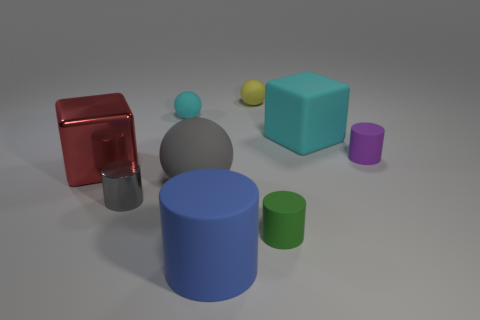Subtract 2 blocks. How many blocks are left? 0 Subtract all cyan spheres. How many spheres are left? 2 Subtract all small balls. How many balls are left? 1 Add 5 small purple rubber cylinders. How many small purple rubber cylinders exist? 6 Subtract 0 blue balls. How many objects are left? 9 Subtract all cylinders. How many objects are left? 5 Subtract all green cylinders. Subtract all yellow spheres. How many cylinders are left? 3 Subtract all red blocks. How many blue cylinders are left? 1 Subtract all small purple rubber cylinders. Subtract all tiny spheres. How many objects are left? 6 Add 3 large blue matte things. How many large blue matte things are left? 4 